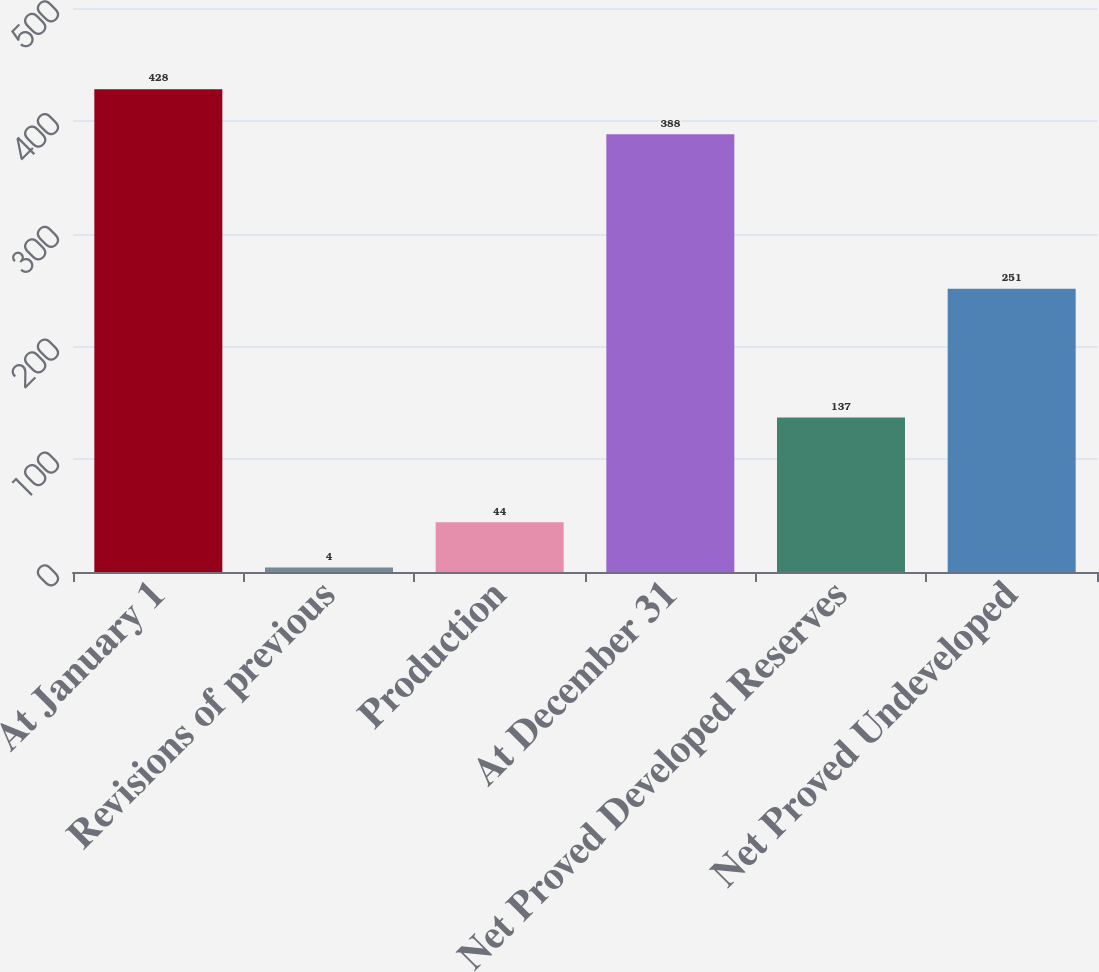Convert chart. <chart><loc_0><loc_0><loc_500><loc_500><bar_chart><fcel>At January 1<fcel>Revisions of previous<fcel>Production<fcel>At December 31<fcel>Net Proved Developed Reserves<fcel>Net Proved Undeveloped<nl><fcel>428<fcel>4<fcel>44<fcel>388<fcel>137<fcel>251<nl></chart> 